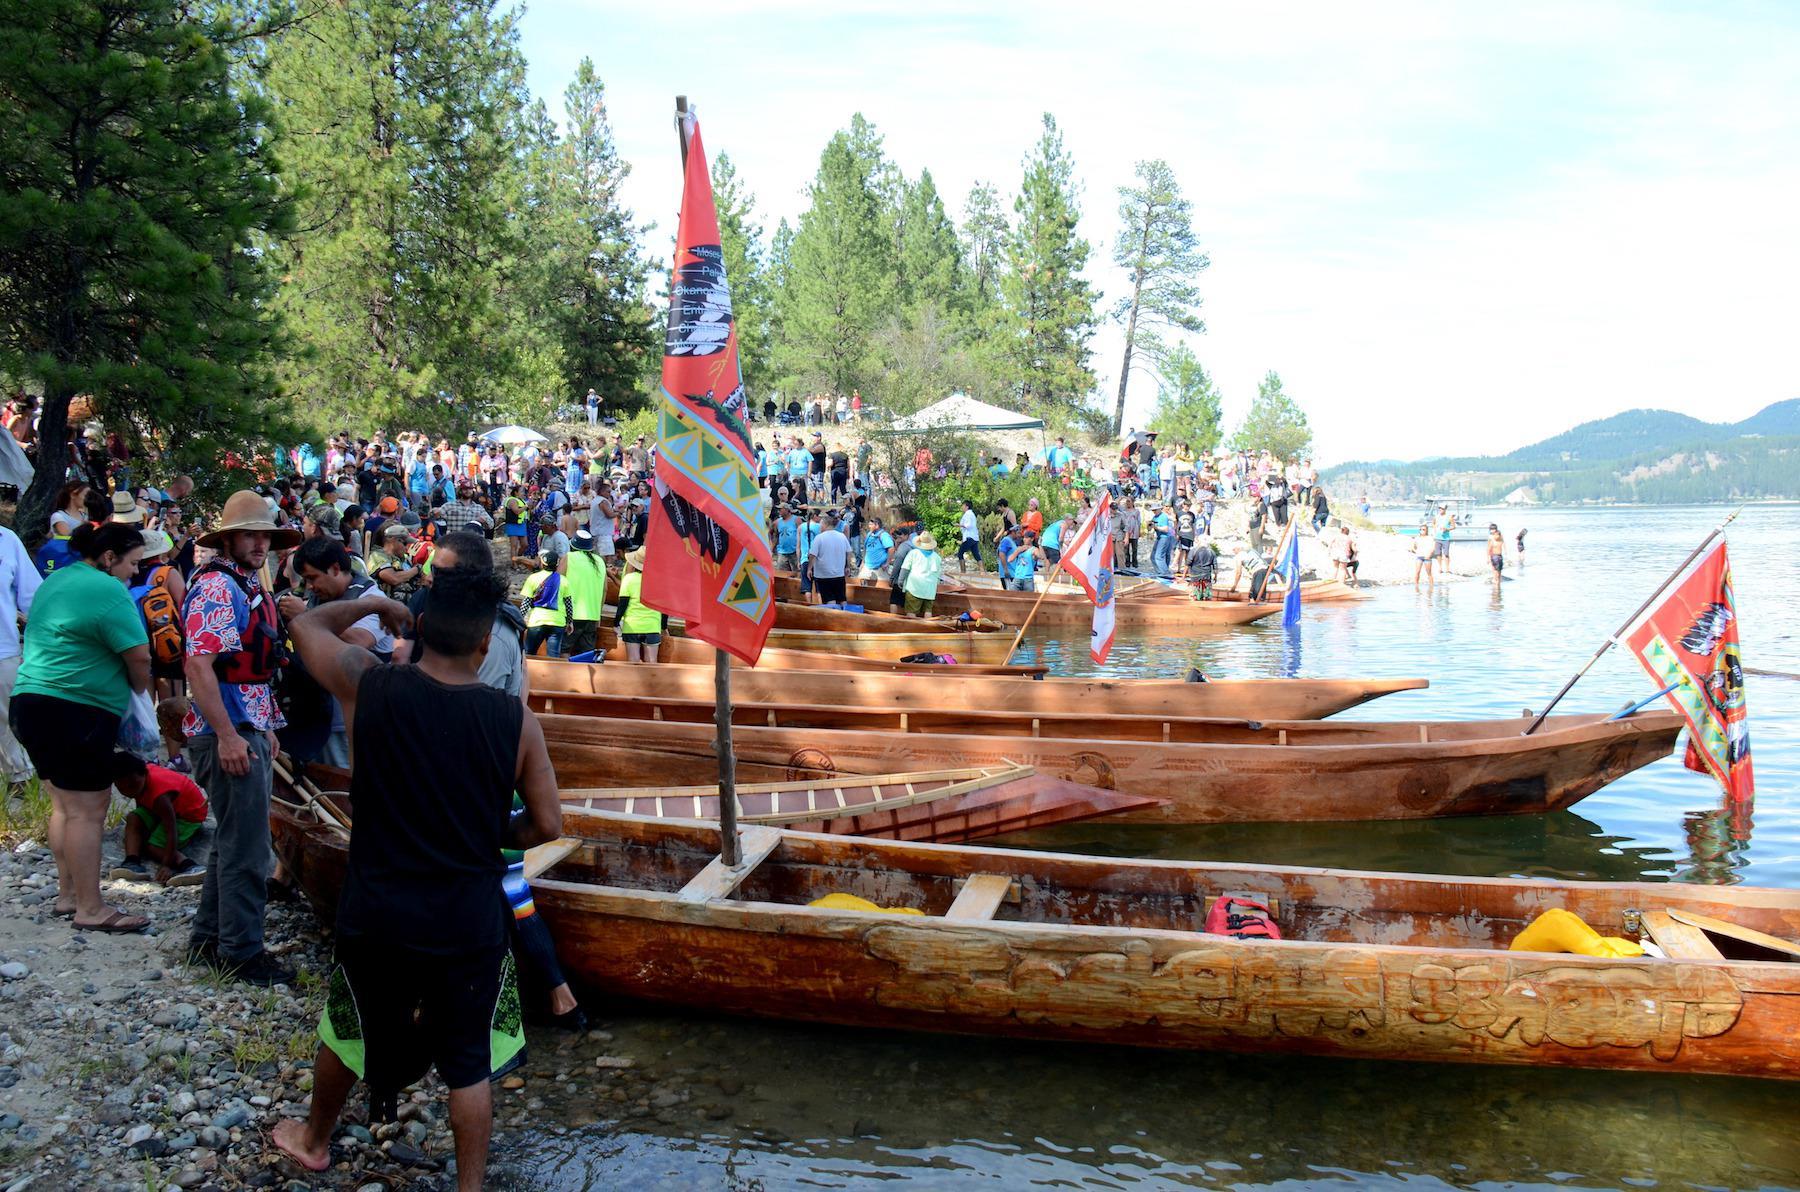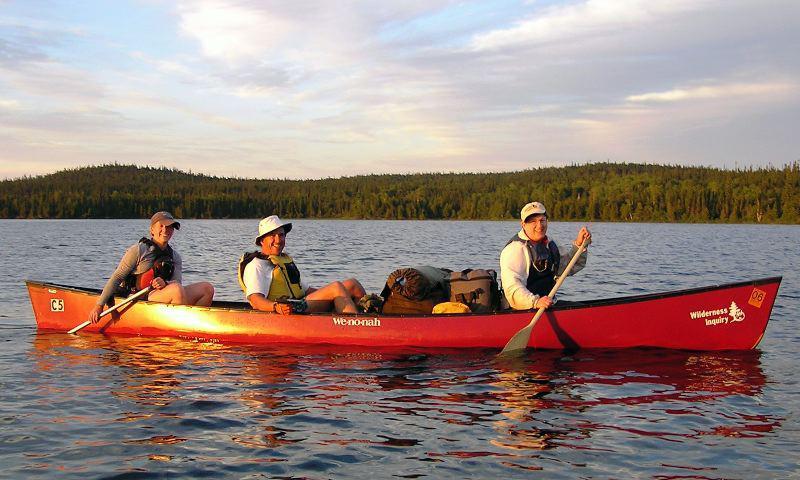The first image is the image on the left, the second image is the image on the right. For the images displayed, is the sentence "Three people ride a red canoe horizontally across the right image." factually correct? Answer yes or no. Yes. 